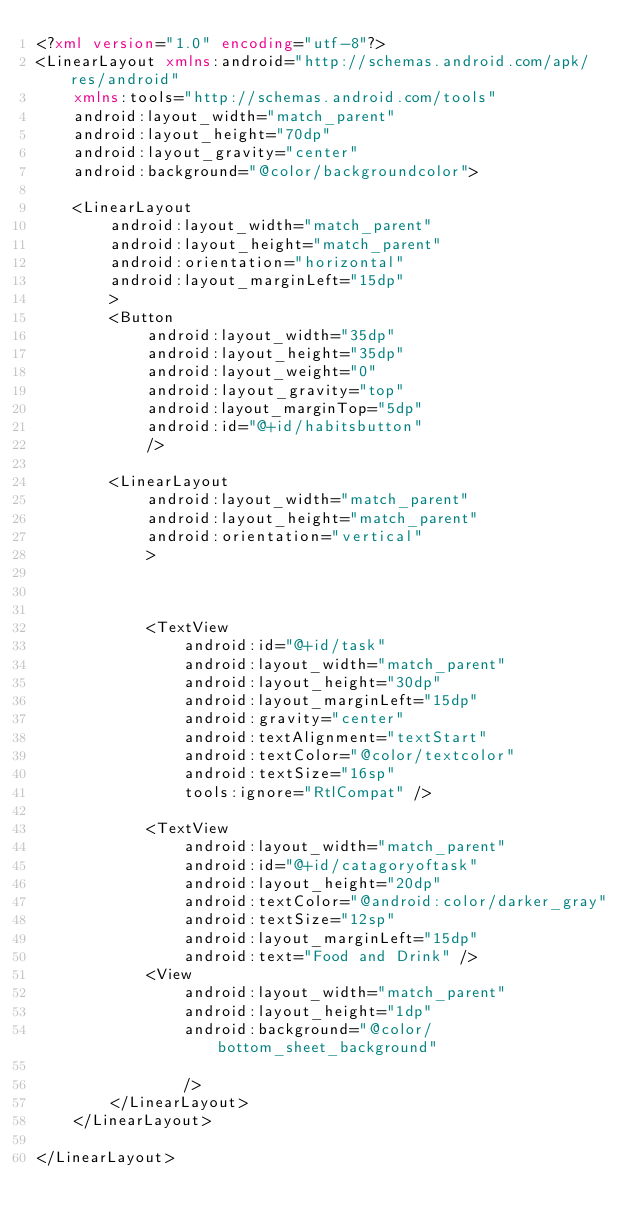<code> <loc_0><loc_0><loc_500><loc_500><_XML_><?xml version="1.0" encoding="utf-8"?>
<LinearLayout xmlns:android="http://schemas.android.com/apk/res/android"
    xmlns:tools="http://schemas.android.com/tools"
    android:layout_width="match_parent"
    android:layout_height="70dp"
    android:layout_gravity="center"
    android:background="@color/backgroundcolor">

    <LinearLayout
        android:layout_width="match_parent"
        android:layout_height="match_parent"
        android:orientation="horizontal"
        android:layout_marginLeft="15dp"
        >
        <Button
            android:layout_width="35dp"
            android:layout_height="35dp"
            android:layout_weight="0"
            android:layout_gravity="top"
            android:layout_marginTop="5dp"
            android:id="@+id/habitsbutton"
            />

        <LinearLayout
            android:layout_width="match_parent"
            android:layout_height="match_parent"
            android:orientation="vertical"
            >



            <TextView
                android:id="@+id/task"
                android:layout_width="match_parent"
                android:layout_height="30dp"
                android:layout_marginLeft="15dp"
                android:gravity="center"
                android:textAlignment="textStart"
                android:textColor="@color/textcolor"
                android:textSize="16sp"
                tools:ignore="RtlCompat" />

            <TextView
                android:layout_width="match_parent"
                android:id="@+id/catagoryoftask"
                android:layout_height="20dp"
                android:textColor="@android:color/darker_gray"
                android:textSize="12sp"
                android:layout_marginLeft="15dp"
                android:text="Food and Drink" />
            <View
                android:layout_width="match_parent"
                android:layout_height="1dp"
                android:background="@color/bottom_sheet_background"

                />
        </LinearLayout>
    </LinearLayout>

</LinearLayout>
</code> 